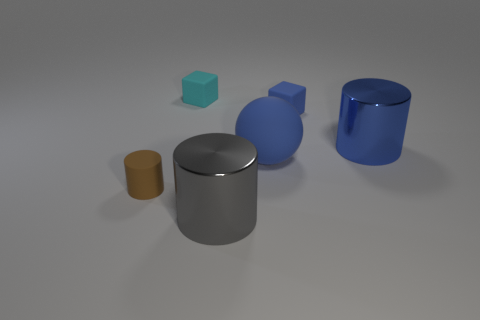The big thing that is both on the left side of the big blue metal object and to the right of the large gray metal thing is made of what material?
Ensure brevity in your answer.  Rubber. The other big metallic object that is the same shape as the gray thing is what color?
Provide a short and direct response. Blue. Is there a large rubber sphere that is behind the cylinder on the right side of the gray metal object?
Give a very brief answer. No. The brown rubber object has what size?
Offer a terse response. Small. What shape is the tiny matte object that is both in front of the cyan matte object and to the right of the tiny brown matte object?
Offer a very short reply. Cube. How many red objects are either cubes or large cylinders?
Your answer should be compact. 0. There is a matte block behind the tiny blue matte object; is it the same size as the matte thing that is in front of the large ball?
Offer a terse response. Yes. How many objects are large yellow metal balls or large blue shiny objects?
Make the answer very short. 1. Is there a big blue thing that has the same shape as the brown object?
Give a very brief answer. Yes. Are there fewer large green matte blocks than tiny cyan matte things?
Your response must be concise. Yes. 